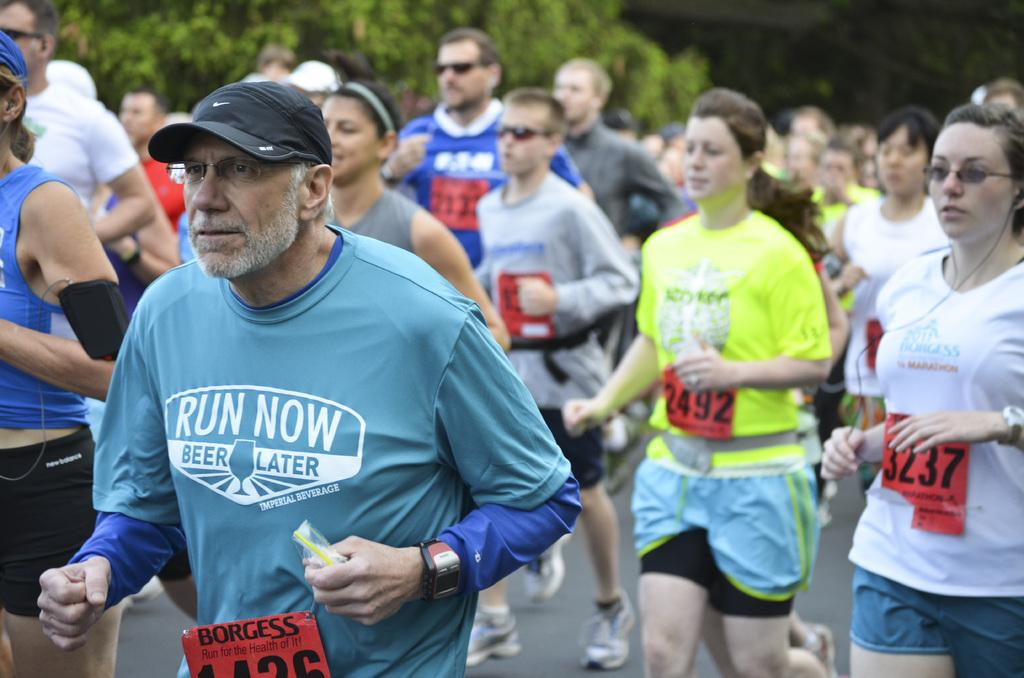What types of people are in the image? There are men and women in the image. What are the people in the image doing? They are walking on a road. What natural element is present in the image? There is a tree in the image. Can you describe the object being held by one of the men? A man is holding an object in the image. What type of balls are being distributed by the women in the image? There are no balls or distribution activity present in the image. 